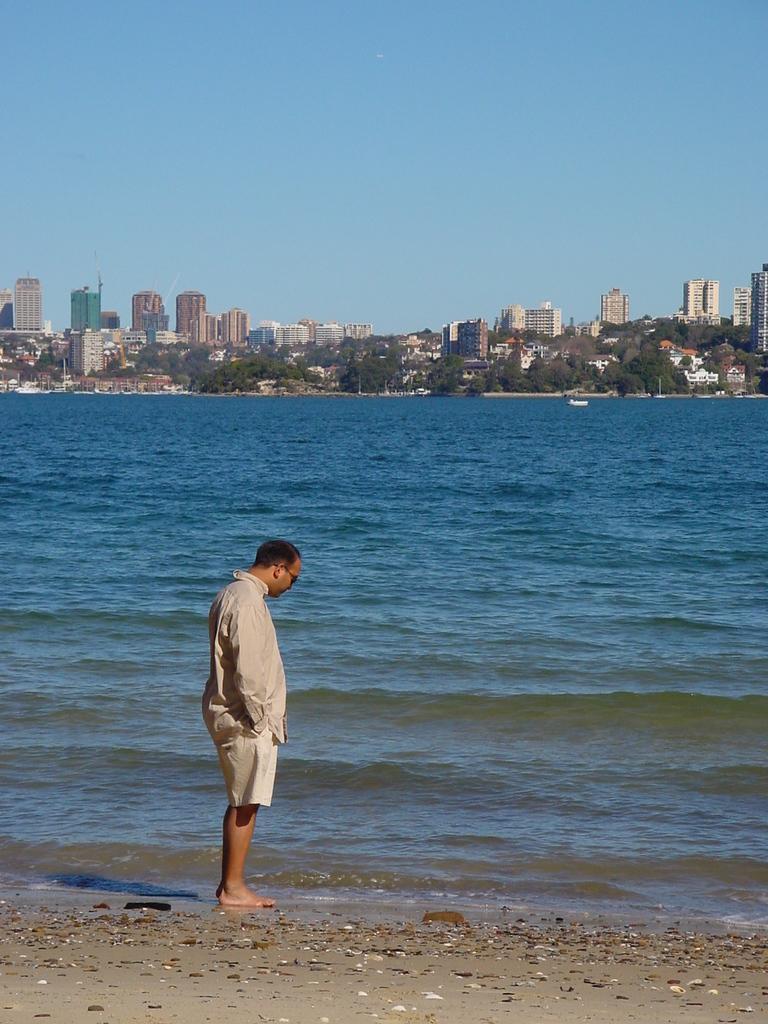Please provide a concise description of this image. In this image, we can see a person is standing on the seashore. Background we can see water, trees, buildings, poles and sky. 